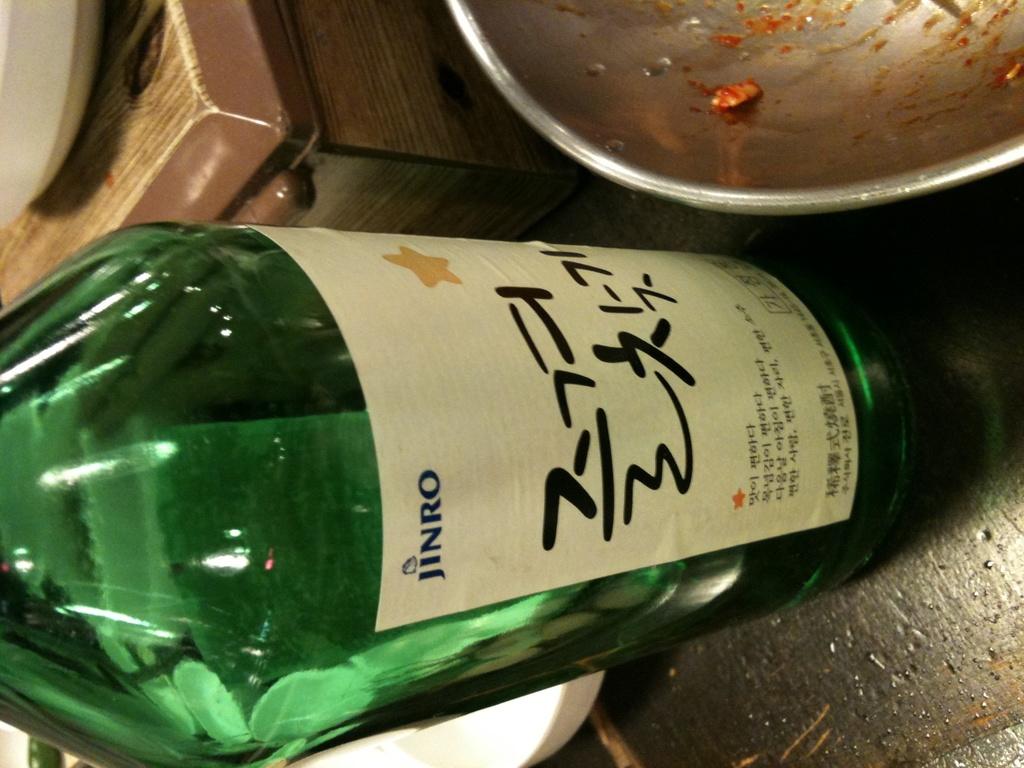What color is the bottle?
Provide a succinct answer. Answering does not require reading text in the image. What is the brand name on the bottle on the top of the label?
Make the answer very short. Jinro. 